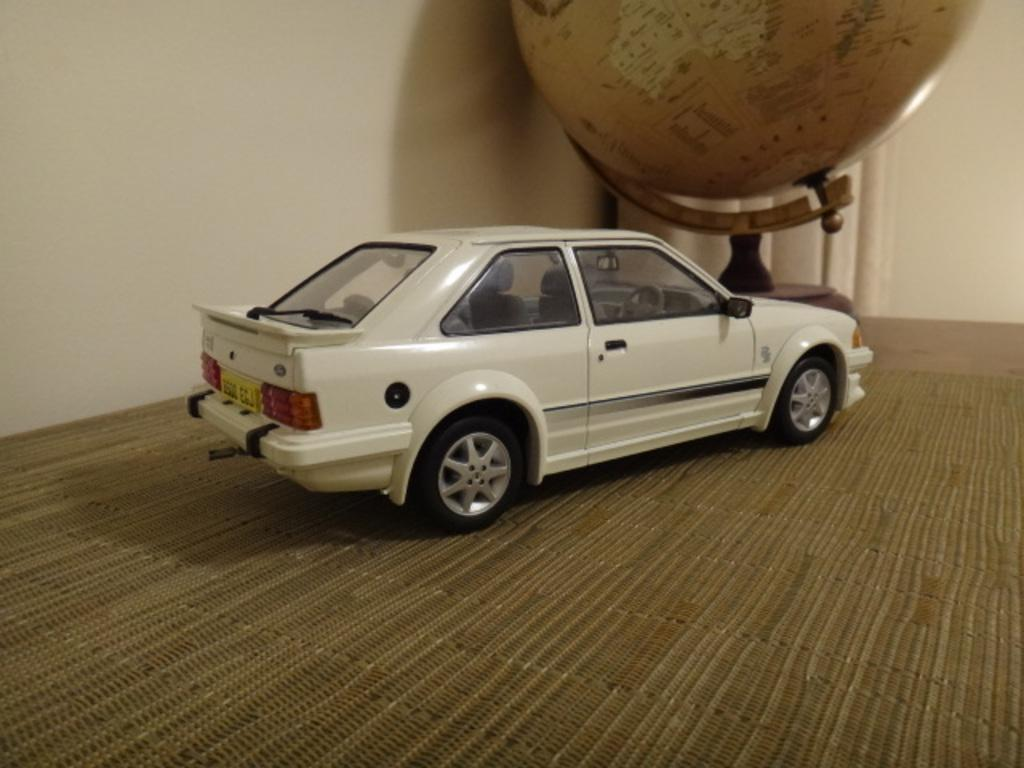What object is placed on the table in the image? There is a toy car on the table. What is positioned in front of the toy car? There is a globe in front of the toy car. What can be seen in the background of the image? There is a wall in the background of the image. Where is the girl sitting with the cabbage and hammer in the image? There is no girl, cabbage, or hammer present in the image. 